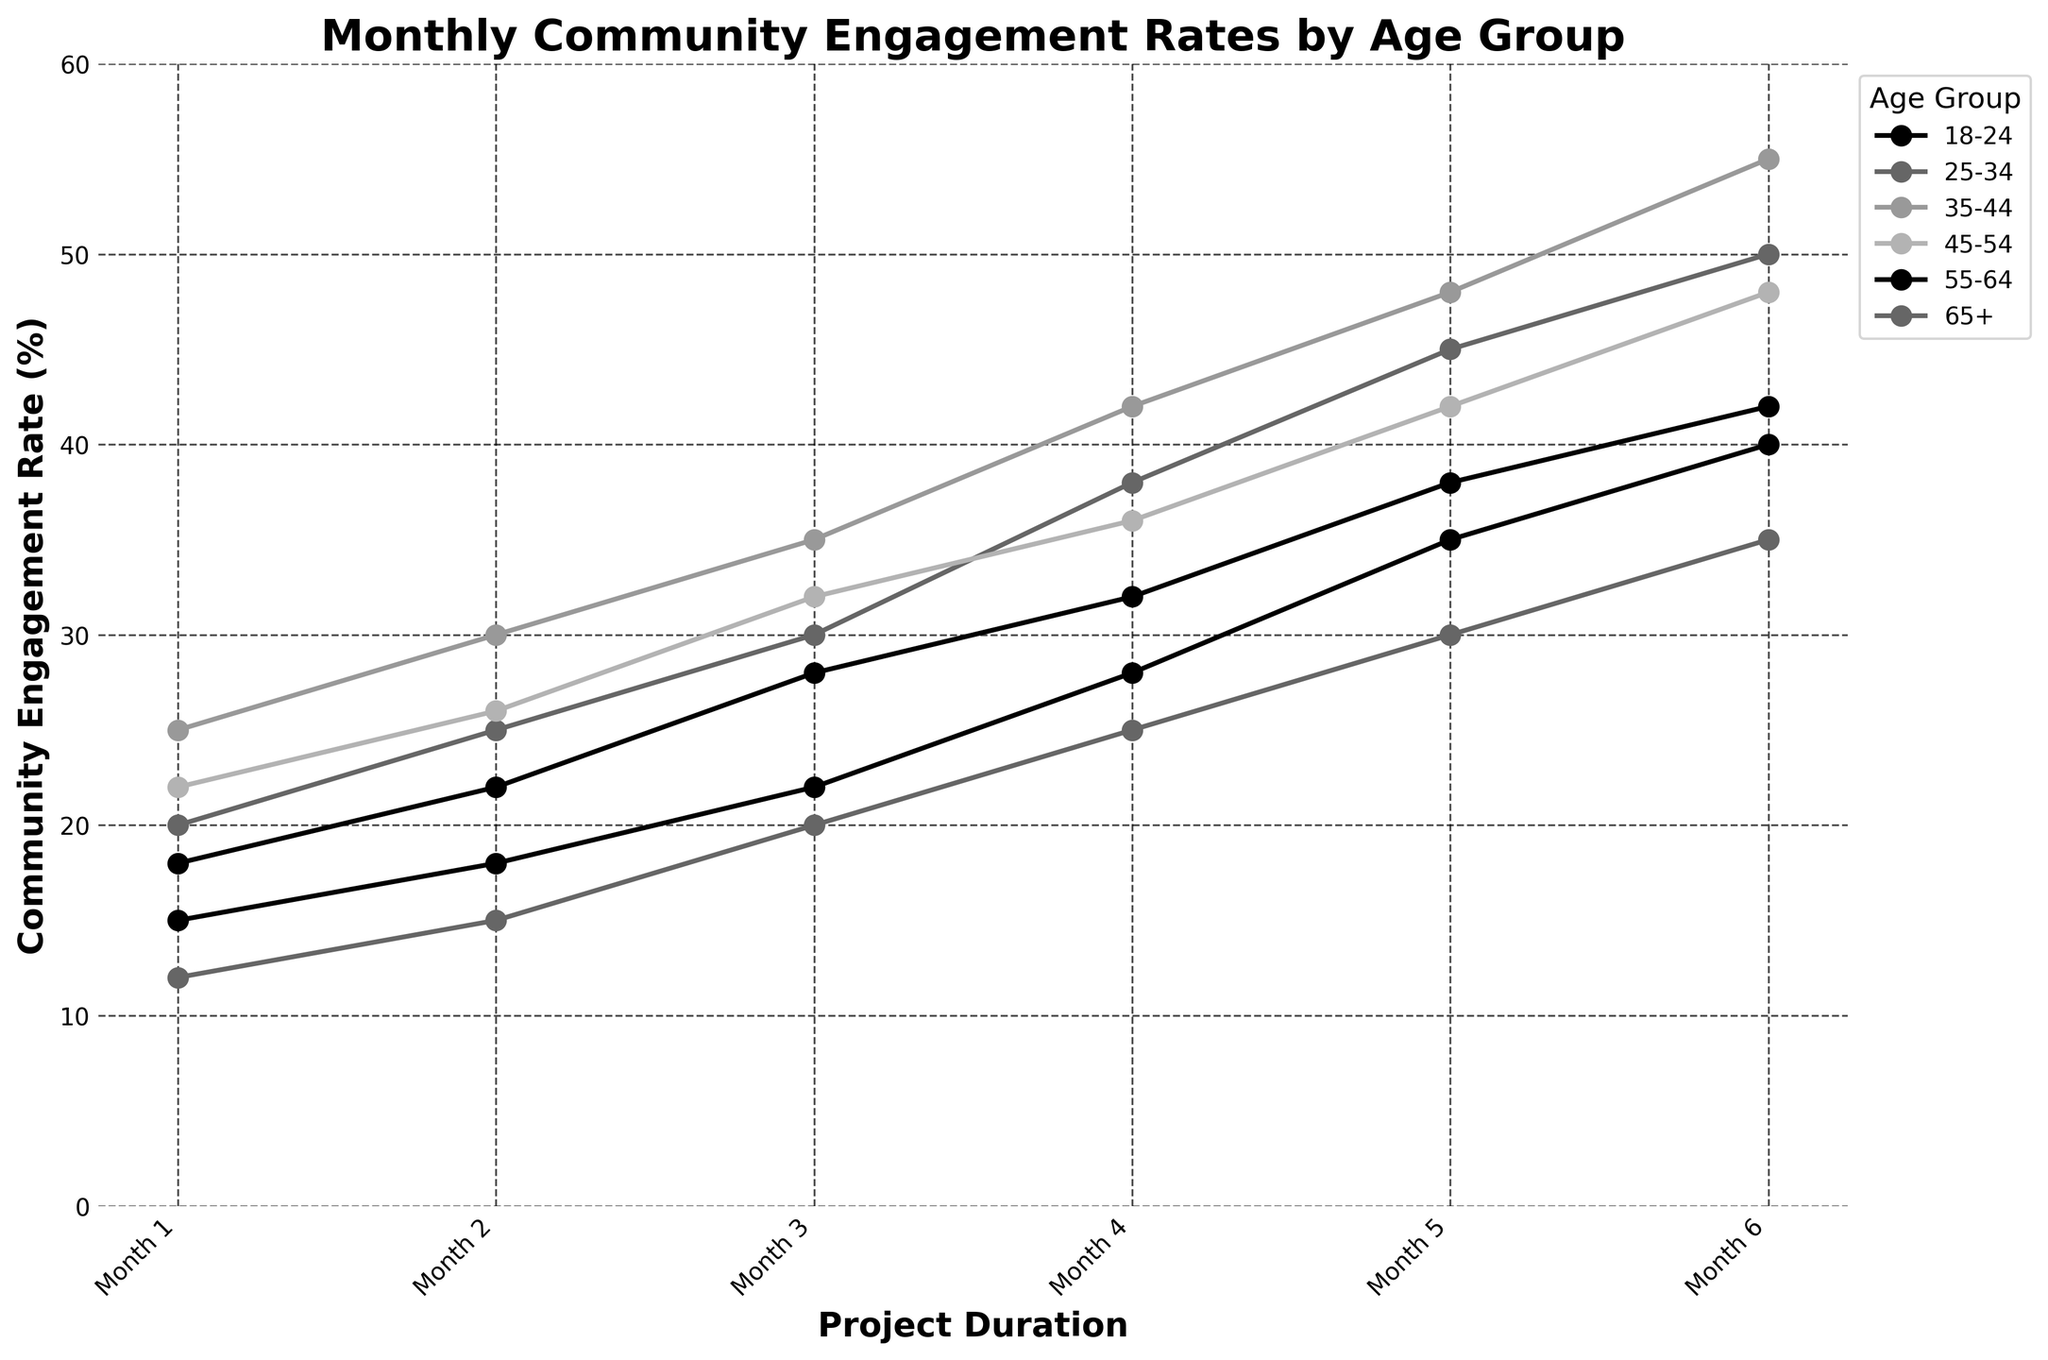What is the average community engagement rate for the 18-24 age group over the six months? Sum the rates for each month (15 + 18 + 22 + 28 + 35 + 40 = 158) and divide by the number of months (6). So, the average engagement rate is 158 / 6 ≈ 26.33
Answer: 26.33 Which age group had the highest community engagement rate by Month 6? Compare the engagement rates of all age groups in Month 6. The values are as follows: 18-24: 40, 25-34: 50, 35-44: 55, 45-54: 48, 55-64: 42, 65+: 35. The highest rate is 55 (35-44 age group).
Answer: 35-44 Did any age group experience a decrease in the engagement rate across any months? Check the engagement rates month-to-month for each age group. No age group shows a decrease in any month-to-month value; each rate either increases or stays the same.
Answer: No What is the cumulative increase in the engagement rate for the 55-64 age group from Month 1 to Month 6? Subtract the Month 1 rate from the Month 6 rate (42 - 18 = 24).
Answer: 24 Between Months 2 and 4, which age group showed the greatest increase in the engagement rate? Calculate the increase for each age group from Month 2 to Month 4:
18-24: 28 - 18 = 10
25-34: 38 - 25 = 13
35-44: 42 - 30 = 12
45-54: 36 - 26 = 10
55-64: 32 - 22 = 10
65+: 25 - 15 = 10
The greatest increase is for the 25-34 age group (13).
Answer: 25-34 Which age group had the lowest average engagement rate over the six-month period? Calculate the average for each age group, then compare them:
18-24: (158 / 6) ≈ 26.33
25-34: (208 / 6) ≈ 34.67
35-44: (235 / 6) ≈ 39.17
45-54: (206 / 6) ≈ 34.33
55-64: (180 / 6) ≈ 30.00
65+: (137 / 6) ≈ 22.83
The lowest average rate is for the 65+ age group.
Answer: 65+ Visually, which age group's engagement rate line is the highest above all others in Month 3? Compare the plotted lines visually at Month 3. The highest line at that point is for the 35-44 age group.
Answer: 35-44 